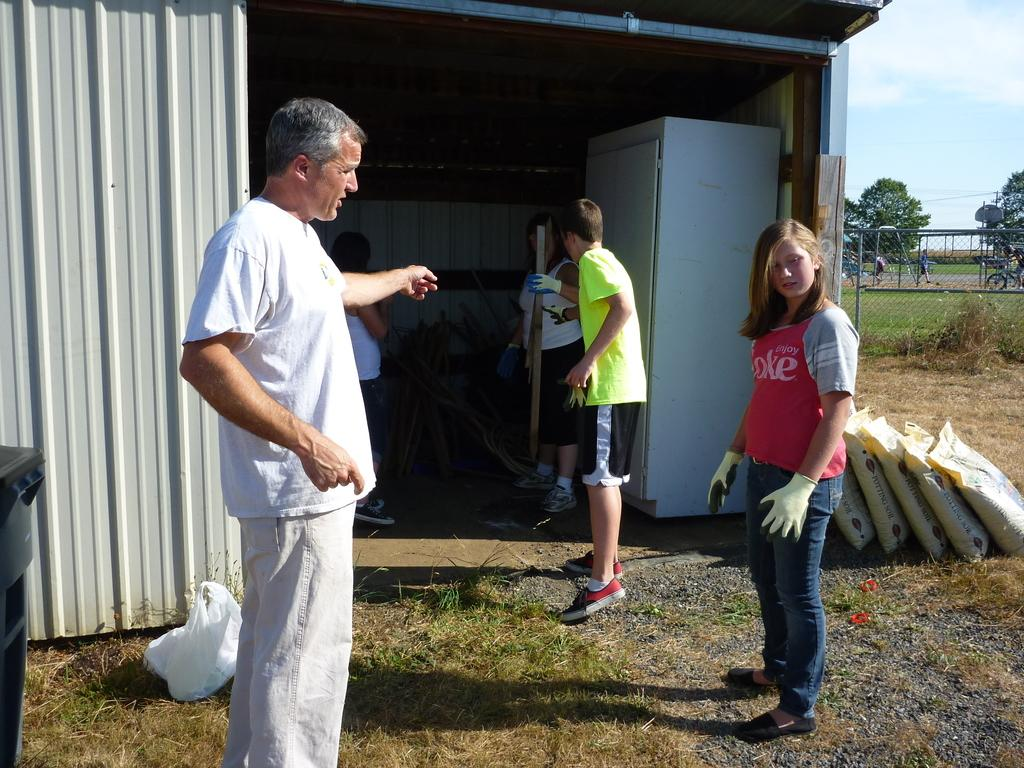How many people are in the image? There is a group of people in the image, but the exact number is not specified. What type of structure is present in the image? There is an iron shed in the image. What type of barrier is visible in the image? There is fencing in the image. What type of vegetation is present in the image? There is grass in the image. What type of objects are present in the image? There are sacks in the image. What type of natural elements are present in the image? There are trees in the image. What is visible in the background of the image? The sky is visible in the background of the image. Can you tell me how many eggs are in the toad's nest in the image? There is no toad or nest present in the image, so it is not possible to answer that question. 